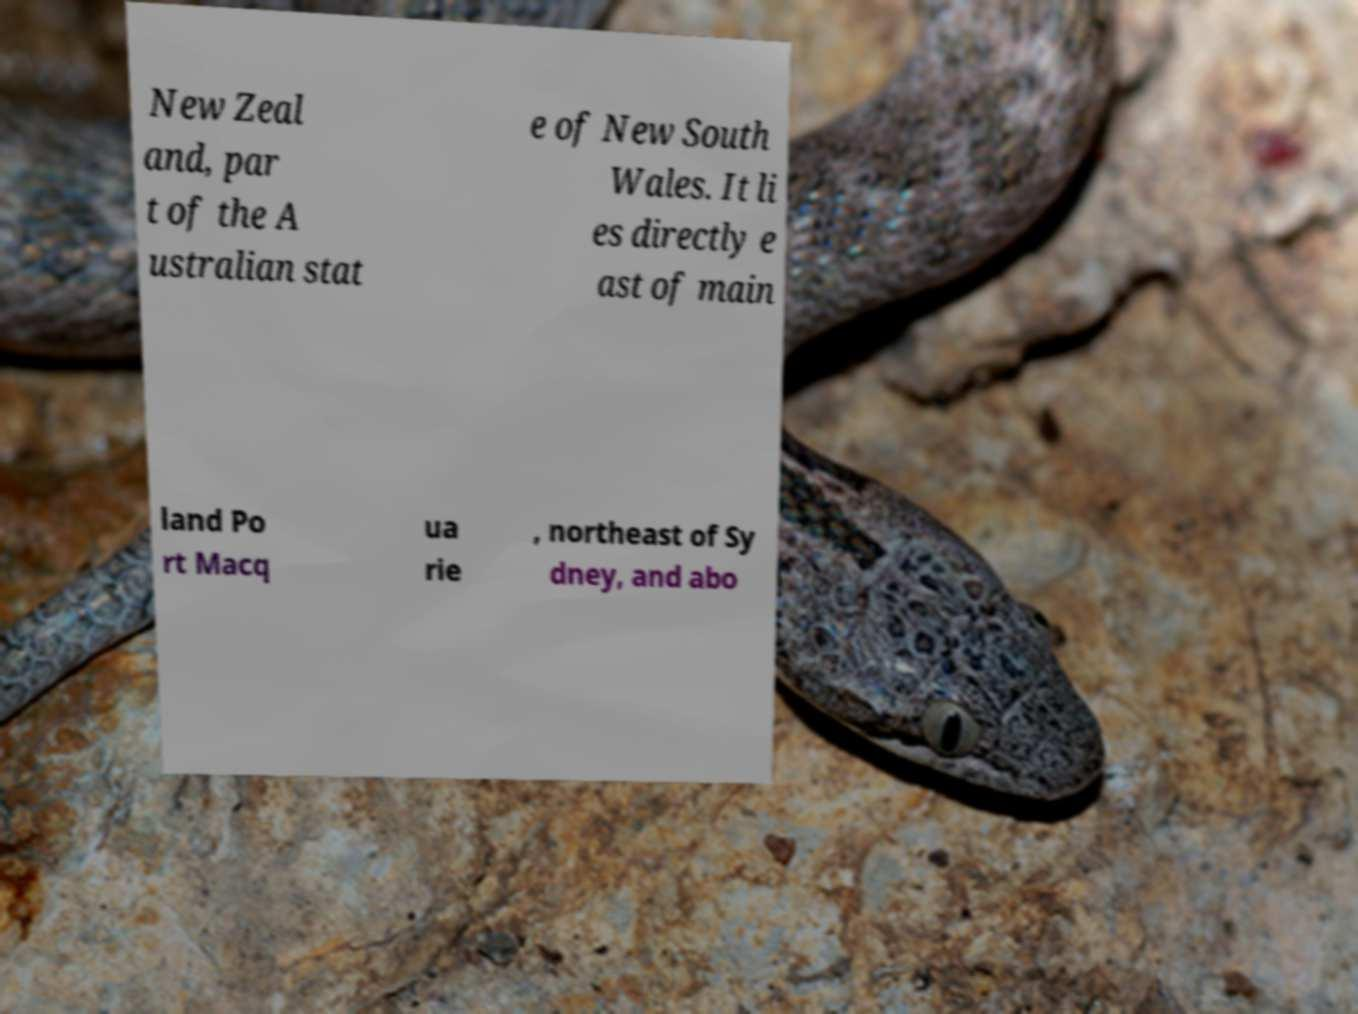Could you extract and type out the text from this image? New Zeal and, par t of the A ustralian stat e of New South Wales. It li es directly e ast of main land Po rt Macq ua rie , northeast of Sy dney, and abo 